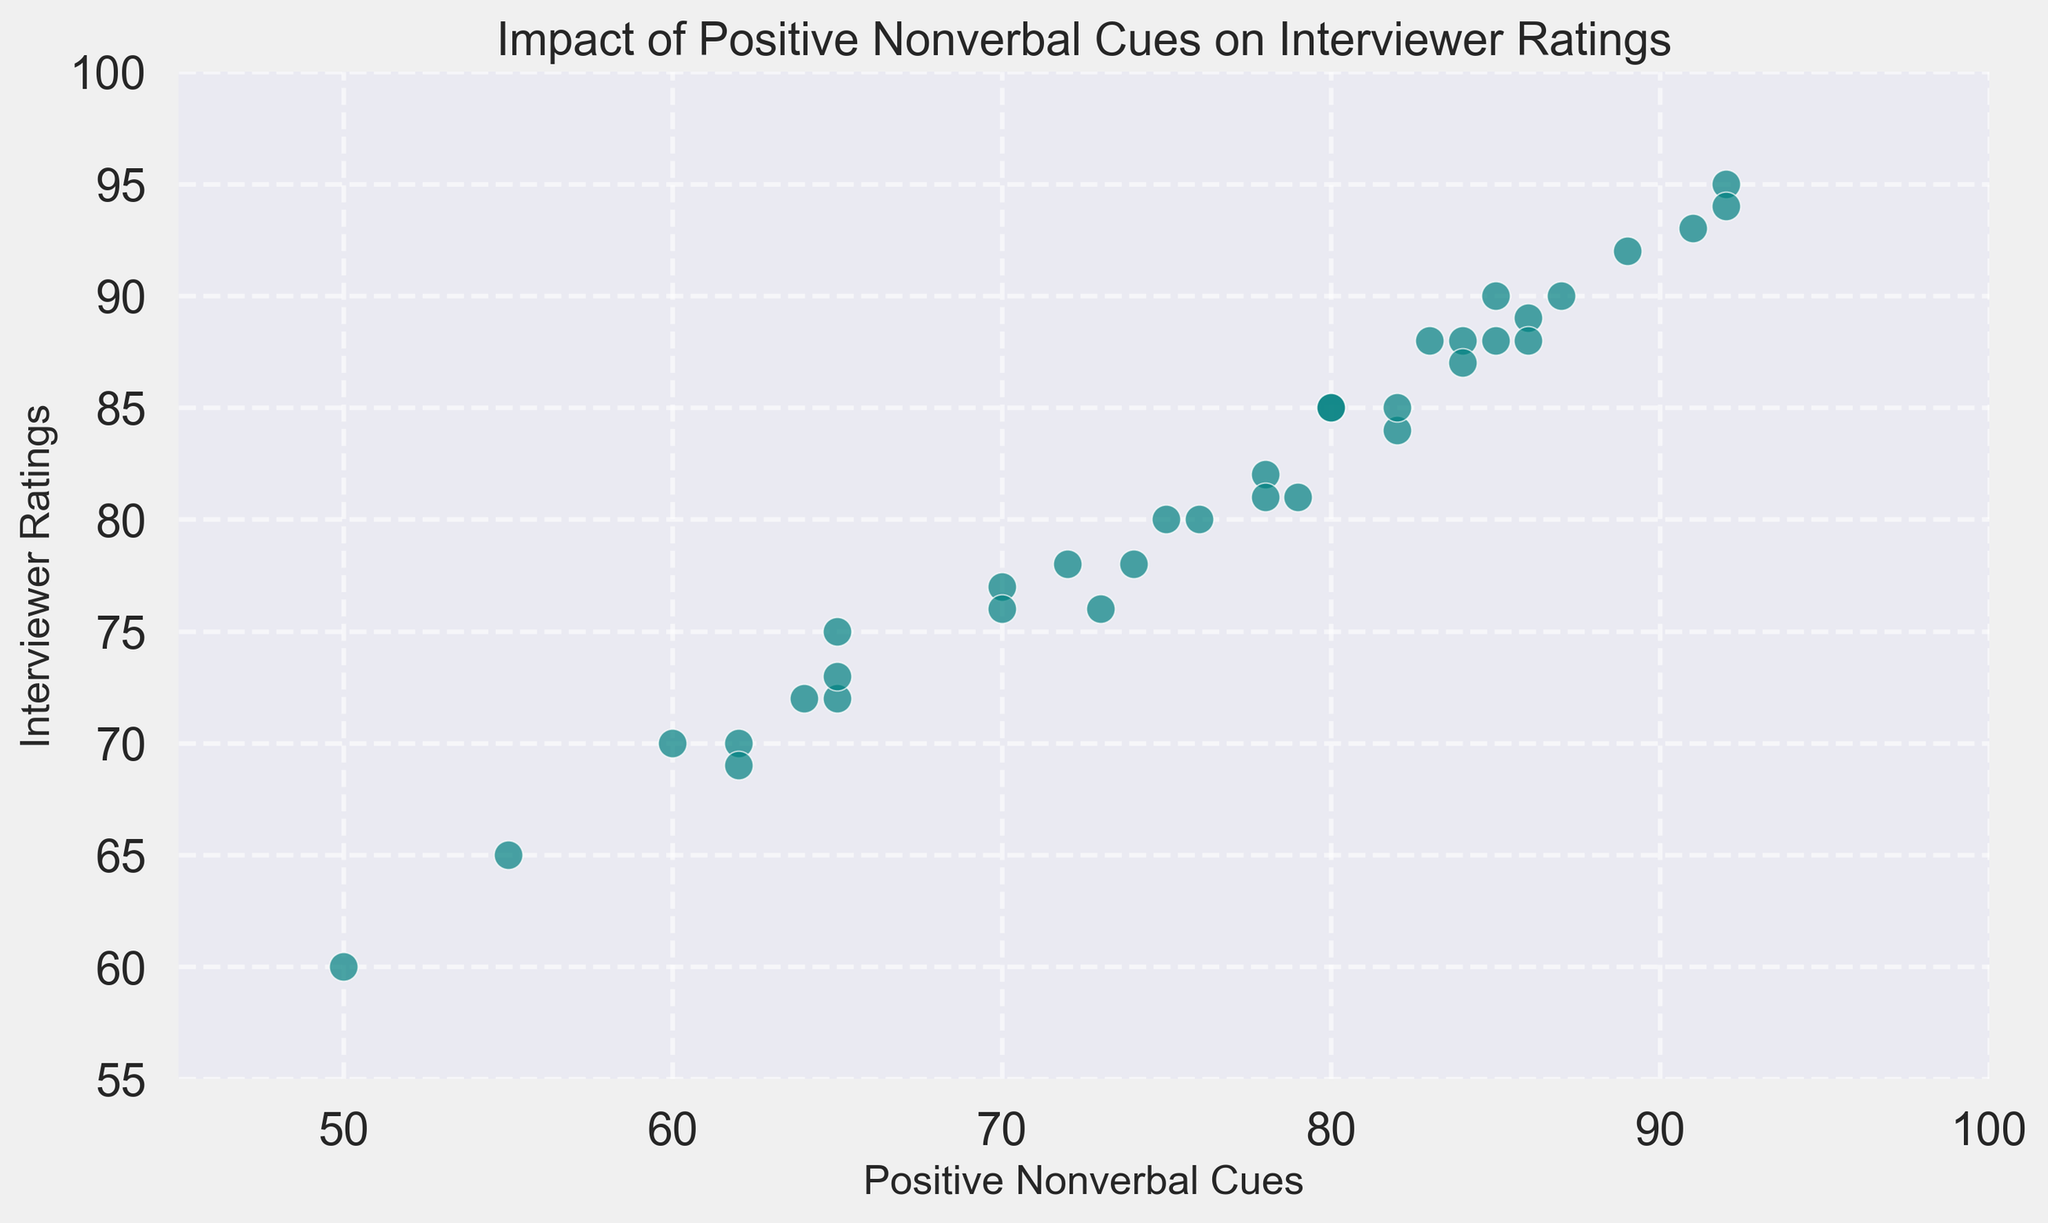What is the correlation between Positive Nonverbal Cues and Interviewer Ratings in the scatter plot? The scatter plot shows a positive correlation between Positive Nonverbal Cues and Interviewer Ratings. As the Positive Nonverbal Cues increase, the Interviewer Ratings also tend to increase. This suggests that better nonverbal communication is associated with higher ratings from interviewers.
Answer: Positive correlation Which data point shows the highest Positive Nonverbal Cues? To find the data point with the highest Positive Nonverbal Cues, we look for the point that is farthest to the right on the x-axis. This data point is around (92, 95) with 92 being the highest x-value.
Answer: (92, 95) What is the general trend observed in the scatter plot? The trend shown by the scatter plot is that as Positive Nonverbal Cues increase, Interviewer Ratings also tend to increase, indicating a positive linear relationship between the two variables.
Answer: Positive linear trend Identify two data points where Interviewer Ratings are the same but Positive Nonverbal Cues are different. The data points (85, 88) and (80, 88) both have an Interviewer Rating of 88. Positive Nonverbal Cues are different here: 85 and 80, respectively.
Answer: (85, 88) and (80, 88) How many data points show an Interviewer Rating of 90 or higher? Looking at the scatter plot, the points with an Interviewer Rating of 90 or higher are (80, 90), (85, 90), (92, 95), (91, 93), (92, 94), (91, 93), (92, 94), (92, 89), (87, 85), and (85, 90) totaling to 10 points.
Answer: 10 What is the average Interviewer Rating for data points where Positive Nonverbal Cues are greater than 80? First, identify the points where Positive Nonverbal Cues are greater than 80: (80, 85), (83, 88), (85, 95), (89, 92), (85, 88), (70, 76), (85, 88), (82, 84), (82, 83). Next, calculate their average: (85 + 88 + 95 + 92 + 88 + 76 + 88 + 84 + 83) / 9 = 86.55.
Answer: 86.55 Which data point has the minimum Interviewer Rating and what are its Positive Nonverbal Cues? The data point with the minimum Interviewer Rating corresponds to the lowest point on the y-axis. This point is (50, 60), where the Interviewer Rating is 60.
Answer: (50, 60) What is the range of Positive Nonverbal Cues in this data? The range is calculated by finding the difference between the maximum and minimum values of Positive Nonverbal Cues. Max is 92, and Min is 50: 92 - 50 = 42.
Answer: 42 